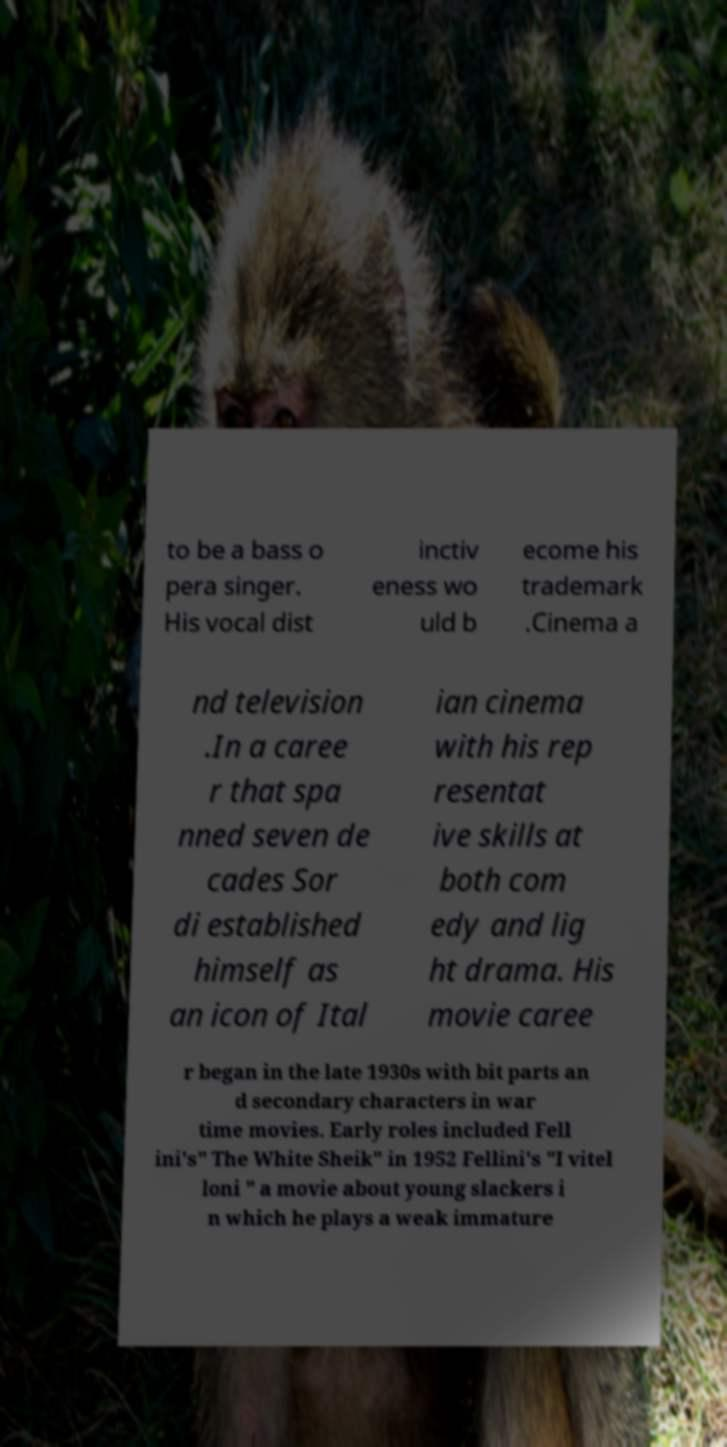Could you assist in decoding the text presented in this image and type it out clearly? to be a bass o pera singer. His vocal dist inctiv eness wo uld b ecome his trademark .Cinema a nd television .In a caree r that spa nned seven de cades Sor di established himself as an icon of Ital ian cinema with his rep resentat ive skills at both com edy and lig ht drama. His movie caree r began in the late 1930s with bit parts an d secondary characters in war time movies. Early roles included Fell ini's" The White Sheik" in 1952 Fellini's "I vitel loni " a movie about young slackers i n which he plays a weak immature 